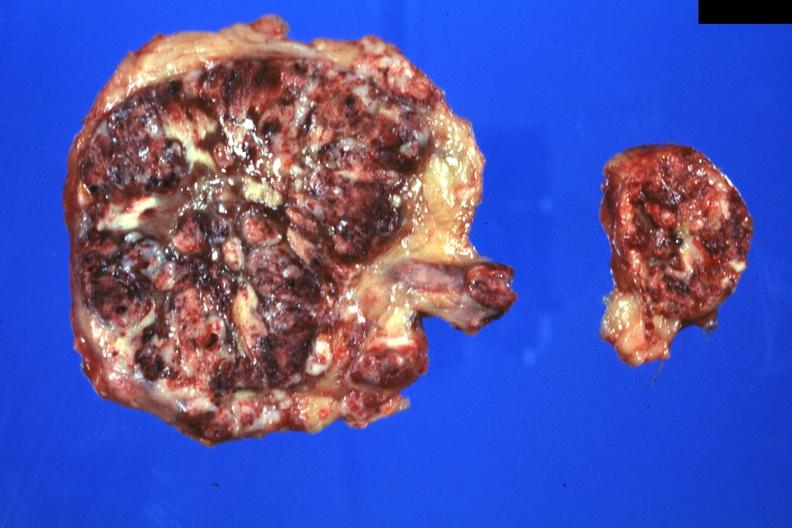where does this belong to?
Answer the question using a single word or phrase. Endocrine system 